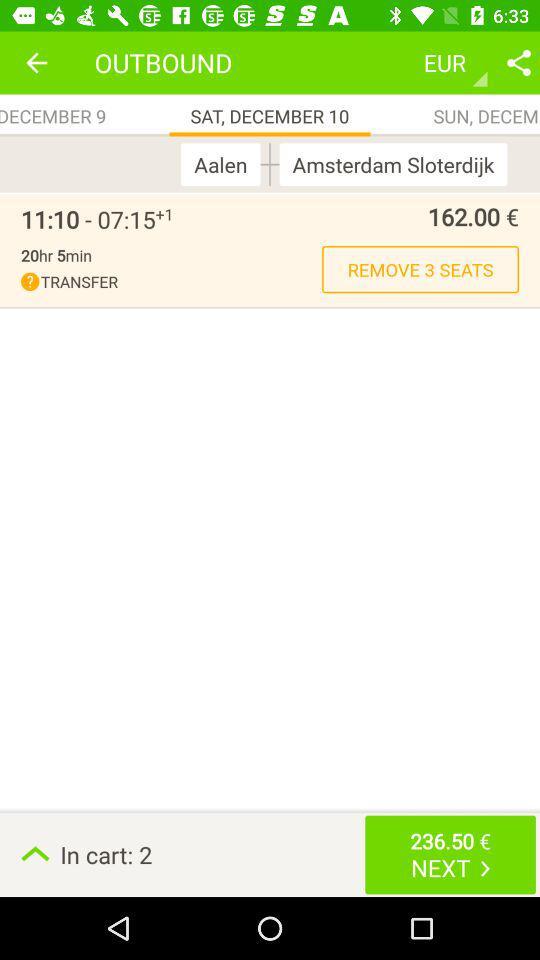For which date is the ticket being booked? The ticket is being booked for Saturday, December 10. 